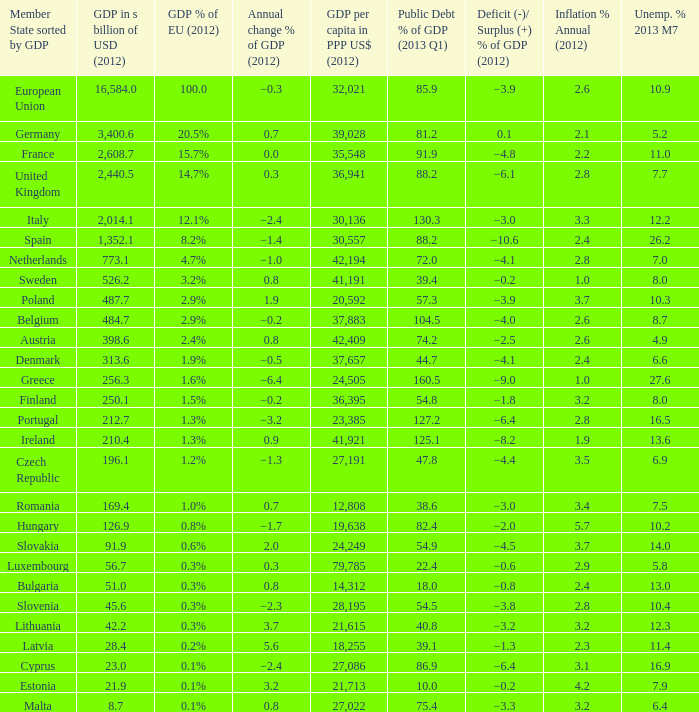What is the greatest annual inflation rate in 2012 for the country with a public debt ratio of gdp in 2013 q1 above 8 2.6. 